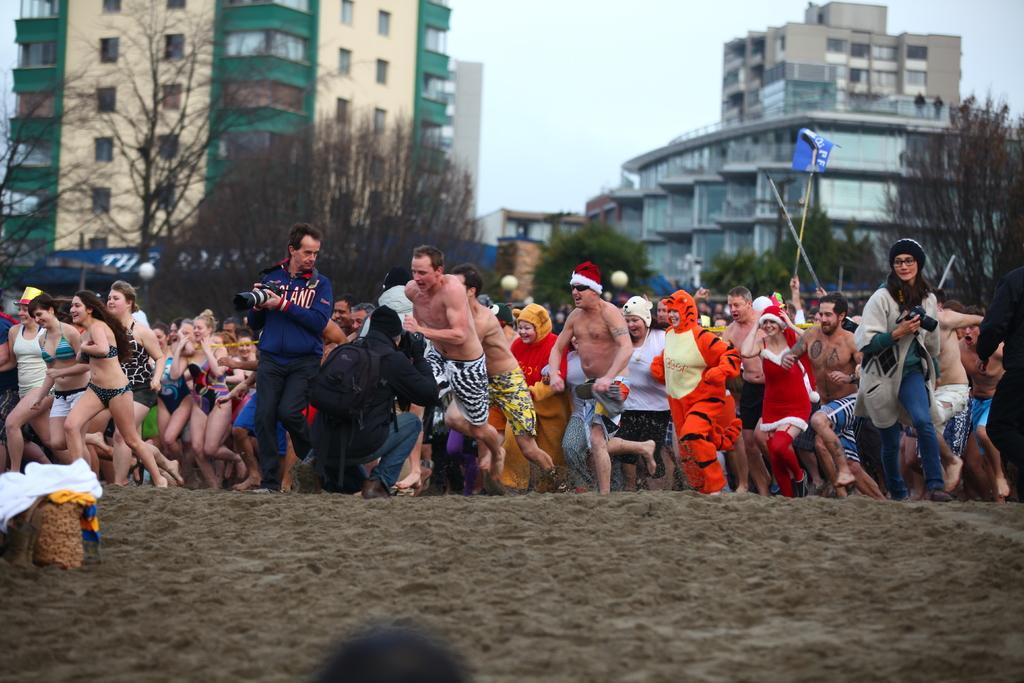Please provide a concise description of this image. This image consists of so many people in the middle. They are running. There are trees in the middle. There are buildings in the middle. There is sky at the top. 